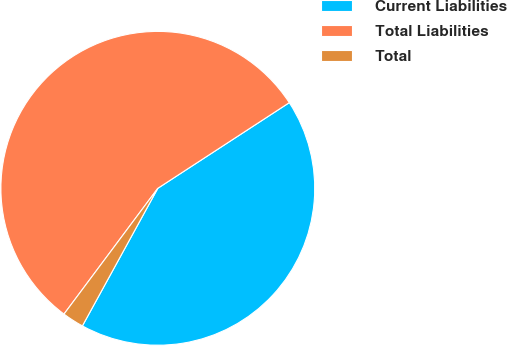Convert chart to OTSL. <chart><loc_0><loc_0><loc_500><loc_500><pie_chart><fcel>Current Liabilities<fcel>Total Liabilities<fcel>Total<nl><fcel>42.17%<fcel>55.61%<fcel>2.22%<nl></chart> 